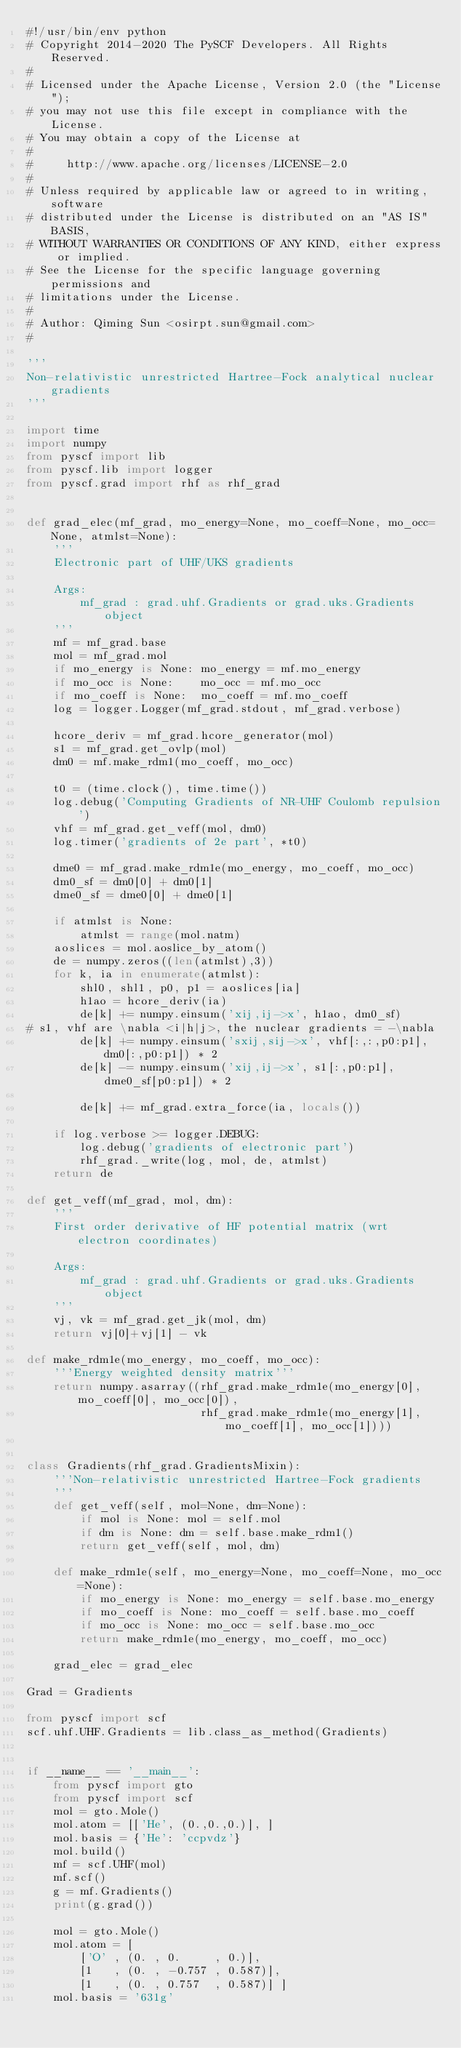Convert code to text. <code><loc_0><loc_0><loc_500><loc_500><_Python_>#!/usr/bin/env python
# Copyright 2014-2020 The PySCF Developers. All Rights Reserved.
#
# Licensed under the Apache License, Version 2.0 (the "License");
# you may not use this file except in compliance with the License.
# You may obtain a copy of the License at
#
#     http://www.apache.org/licenses/LICENSE-2.0
#
# Unless required by applicable law or agreed to in writing, software
# distributed under the License is distributed on an "AS IS" BASIS,
# WITHOUT WARRANTIES OR CONDITIONS OF ANY KIND, either express or implied.
# See the License for the specific language governing permissions and
# limitations under the License.
#
# Author: Qiming Sun <osirpt.sun@gmail.com>
#

'''
Non-relativistic unrestricted Hartree-Fock analytical nuclear gradients
'''

import time
import numpy
from pyscf import lib
from pyscf.lib import logger
from pyscf.grad import rhf as rhf_grad


def grad_elec(mf_grad, mo_energy=None, mo_coeff=None, mo_occ=None, atmlst=None):
    '''
    Electronic part of UHF/UKS gradients

    Args:
        mf_grad : grad.uhf.Gradients or grad.uks.Gradients object
    '''
    mf = mf_grad.base
    mol = mf_grad.mol
    if mo_energy is None: mo_energy = mf.mo_energy
    if mo_occ is None:    mo_occ = mf.mo_occ
    if mo_coeff is None:  mo_coeff = mf.mo_coeff
    log = logger.Logger(mf_grad.stdout, mf_grad.verbose)

    hcore_deriv = mf_grad.hcore_generator(mol)
    s1 = mf_grad.get_ovlp(mol)
    dm0 = mf.make_rdm1(mo_coeff, mo_occ)

    t0 = (time.clock(), time.time())
    log.debug('Computing Gradients of NR-UHF Coulomb repulsion')
    vhf = mf_grad.get_veff(mol, dm0)
    log.timer('gradients of 2e part', *t0)

    dme0 = mf_grad.make_rdm1e(mo_energy, mo_coeff, mo_occ)
    dm0_sf = dm0[0] + dm0[1]
    dme0_sf = dme0[0] + dme0[1]

    if atmlst is None:
        atmlst = range(mol.natm)
    aoslices = mol.aoslice_by_atom()
    de = numpy.zeros((len(atmlst),3))
    for k, ia in enumerate(atmlst):
        shl0, shl1, p0, p1 = aoslices[ia]
        h1ao = hcore_deriv(ia)
        de[k] += numpy.einsum('xij,ij->x', h1ao, dm0_sf)
# s1, vhf are \nabla <i|h|j>, the nuclear gradients = -\nabla
        de[k] += numpy.einsum('sxij,sij->x', vhf[:,:,p0:p1], dm0[:,p0:p1]) * 2
        de[k] -= numpy.einsum('xij,ij->x', s1[:,p0:p1], dme0_sf[p0:p1]) * 2

        de[k] += mf_grad.extra_force(ia, locals())

    if log.verbose >= logger.DEBUG:
        log.debug('gradients of electronic part')
        rhf_grad._write(log, mol, de, atmlst)
    return de

def get_veff(mf_grad, mol, dm):
    '''
    First order derivative of HF potential matrix (wrt electron coordinates)

    Args:
        mf_grad : grad.uhf.Gradients or grad.uks.Gradients object
    '''
    vj, vk = mf_grad.get_jk(mol, dm)
    return vj[0]+vj[1] - vk

def make_rdm1e(mo_energy, mo_coeff, mo_occ):
    '''Energy weighted density matrix'''
    return numpy.asarray((rhf_grad.make_rdm1e(mo_energy[0], mo_coeff[0], mo_occ[0]),
                          rhf_grad.make_rdm1e(mo_energy[1], mo_coeff[1], mo_occ[1])))


class Gradients(rhf_grad.GradientsMixin):
    '''Non-relativistic unrestricted Hartree-Fock gradients
    '''
    def get_veff(self, mol=None, dm=None):
        if mol is None: mol = self.mol
        if dm is None: dm = self.base.make_rdm1()
        return get_veff(self, mol, dm)

    def make_rdm1e(self, mo_energy=None, mo_coeff=None, mo_occ=None):
        if mo_energy is None: mo_energy = self.base.mo_energy
        if mo_coeff is None: mo_coeff = self.base.mo_coeff
        if mo_occ is None: mo_occ = self.base.mo_occ
        return make_rdm1e(mo_energy, mo_coeff, mo_occ)

    grad_elec = grad_elec

Grad = Gradients

from pyscf import scf
scf.uhf.UHF.Gradients = lib.class_as_method(Gradients)


if __name__ == '__main__':
    from pyscf import gto
    from pyscf import scf
    mol = gto.Mole()
    mol.atom = [['He', (0.,0.,0.)], ]
    mol.basis = {'He': 'ccpvdz'}
    mol.build()
    mf = scf.UHF(mol)
    mf.scf()
    g = mf.Gradients()
    print(g.grad())

    mol = gto.Mole()
    mol.atom = [
        ['O' , (0. , 0.     , 0.)],
        [1   , (0. , -0.757 , 0.587)],
        [1   , (0. , 0.757  , 0.587)] ]
    mol.basis = '631g'</code> 